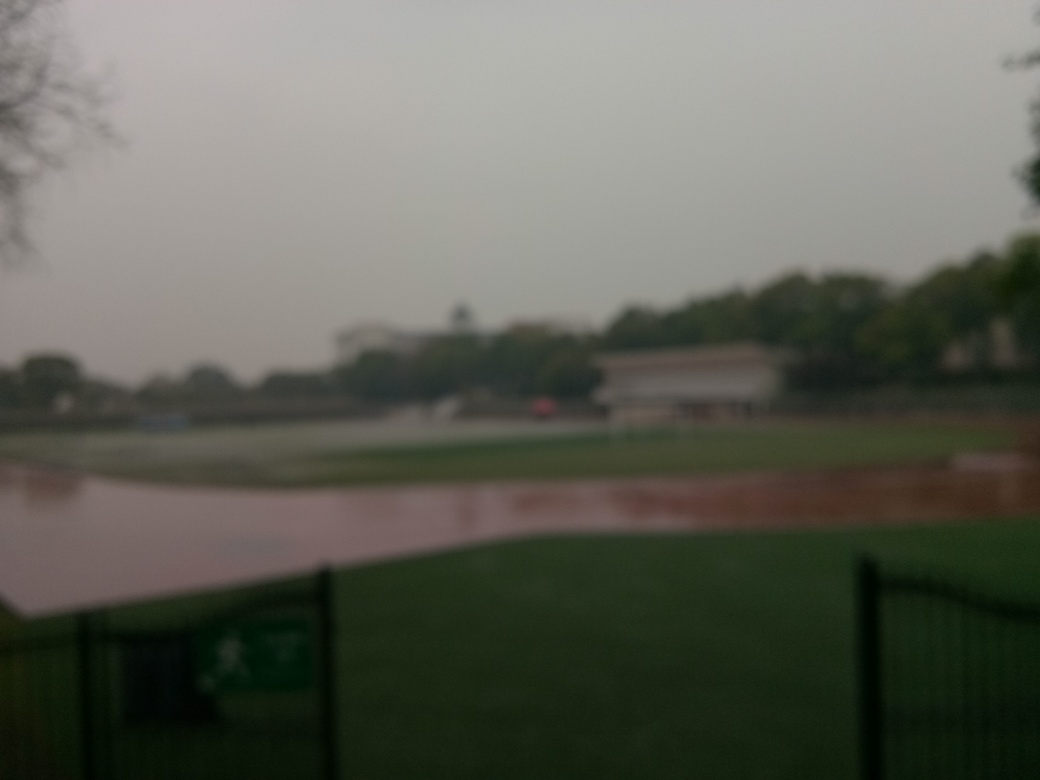Is there any indication of the location or type of setting depicted in the photograph? The photograph appears to depict an outdoor recreational space, such as a park or playing field, as suggested by the open spaces, the fence in the foreground, and structures that resemble park facilities in the blurry background. However, due to the lack of sharp detail, it's difficult to determine any specific landmarks that could reveal the exact location. 